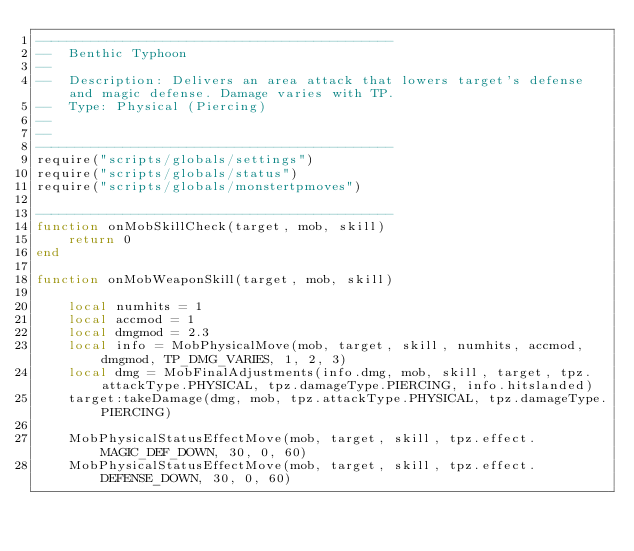<code> <loc_0><loc_0><loc_500><loc_500><_Lua_>---------------------------------------------
--  Benthic Typhoon
--
--  Description: Delivers an area attack that lowers target's defense and magic defense. Damage varies with TP.
--  Type: Physical (Piercing)
--
--
---------------------------------------------
require("scripts/globals/settings")
require("scripts/globals/status")
require("scripts/globals/monstertpmoves")

---------------------------------------------
function onMobSkillCheck(target, mob, skill)
    return 0
end

function onMobWeaponSkill(target, mob, skill)

    local numhits = 1
    local accmod = 1
    local dmgmod = 2.3
    local info = MobPhysicalMove(mob, target, skill, numhits, accmod, dmgmod, TP_DMG_VARIES, 1, 2, 3)
    local dmg = MobFinalAdjustments(info.dmg, mob, skill, target, tpz.attackType.PHYSICAL, tpz.damageType.PIERCING, info.hitslanded)
    target:takeDamage(dmg, mob, tpz.attackType.PHYSICAL, tpz.damageType.PIERCING)

    MobPhysicalStatusEffectMove(mob, target, skill, tpz.effect.MAGIC_DEF_DOWN, 30, 0, 60)
    MobPhysicalStatusEffectMove(mob, target, skill, tpz.effect.DEFENSE_DOWN, 30, 0, 60)
</code> 